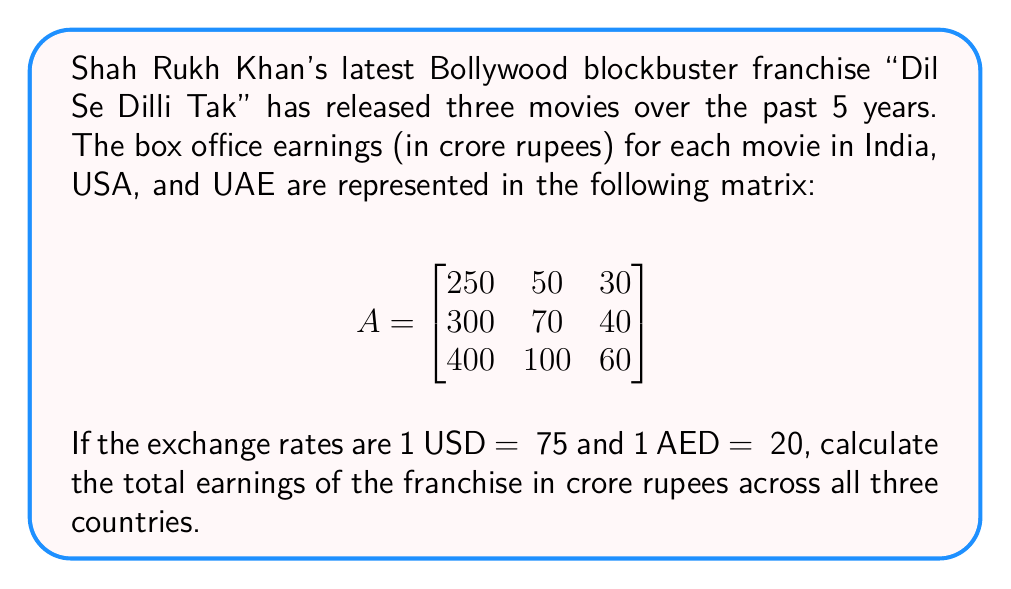What is the answer to this math problem? Let's approach this step-by-step:

1) First, we need to convert all earnings to rupees. The Indian earnings are already in rupees, so we don't need to change those.

2) For USA earnings:
   - Movie 1: 50 crore * 75 = 3750 crore
   - Movie 2: 70 crore * 75 = 5250 crore
   - Movie 3: 100 crore * 75 = 7500 crore

3) For UAE earnings:
   - Movie 1: 30 crore * 20 = 600 crore
   - Movie 2: 40 crore * 20 = 800 crore
   - Movie 3: 60 crore * 20 = 1200 crore

4) Now, we can create a new matrix with all values in rupees:

   $$
   B = \begin{bmatrix}
   250 & 3750 & 600 \\
   300 & 5250 & 800 \\
   400 & 7500 & 1200
   \end{bmatrix}
   $$

5) To find the total earnings, we need to sum all elements of this matrix. We can do this by multiplying the matrix by a column vector of 1s:

   $$
   \begin{bmatrix}
   250 & 3750 & 600 \\
   300 & 5250 & 800 \\
   400 & 7500 & 1200
   \end{bmatrix}
   \begin{bmatrix}
   1 \\
   1 \\
   1
   \end{bmatrix}
   =
   \begin{bmatrix}
   4600 \\
   6350 \\
   9100
   \end{bmatrix}
   $$

6) The result is a column vector. The sum of its elements gives us the total earnings:

   $4600 + 6350 + 9100 = 20050$ crore rupees
Answer: ₹20,050 crore 